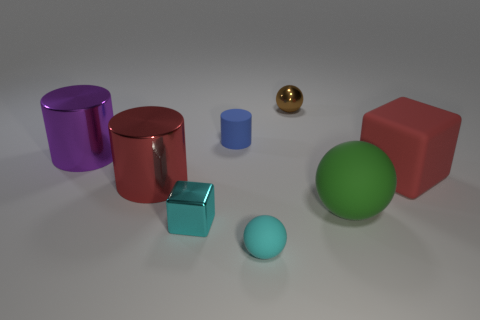How many things are big objects to the right of the blue matte cylinder or tiny shiny objects behind the purple cylinder? Upon examining the image, there is one large red matte cube to the right of the blue matte cylinder. There are no tiny shiny objects behind the purple cylinder. Therefore, the total count is one. 